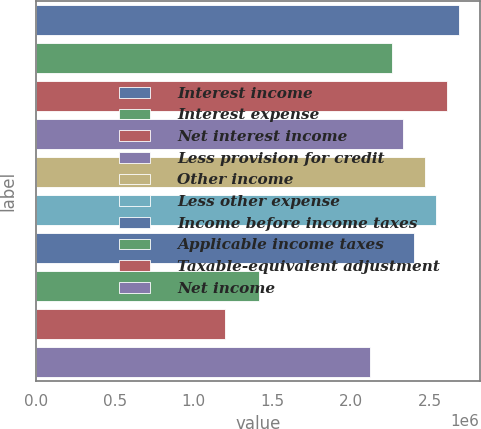<chart> <loc_0><loc_0><loc_500><loc_500><bar_chart><fcel>Interest income<fcel>Interest expense<fcel>Net interest income<fcel>Less provision for credit<fcel>Other income<fcel>Less other expense<fcel>Income before income taxes<fcel>Applicable income taxes<fcel>Taxable-equivalent adjustment<fcel>Net income<nl><fcel>2.68427e+06<fcel>2.26044e+06<fcel>2.61363e+06<fcel>2.33108e+06<fcel>2.47236e+06<fcel>2.54299e+06<fcel>2.40172e+06<fcel>1.41278e+06<fcel>1.20086e+06<fcel>2.11916e+06<nl></chart> 